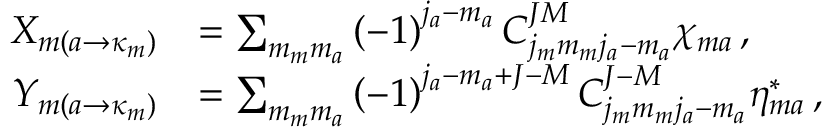<formula> <loc_0><loc_0><loc_500><loc_500>\begin{array} { r l } { X _ { m \left ( a \rightarrow \kappa _ { m } \right ) } } & { = \sum _ { m _ { m } m _ { a } } \left ( - 1 \right ) ^ { j _ { a } - m _ { a } } C _ { j _ { m } m _ { m } j _ { a } - m _ { a } } ^ { J M } \chi _ { m a } \, , } \\ { Y _ { m \left ( a \rightarrow \kappa _ { m } \right ) } } & { = \sum _ { m _ { m } m _ { a } } \left ( - 1 \right ) ^ { j _ { a } - m _ { a } + J - M } C _ { j _ { m } m _ { m } j _ { a } - m _ { a } } ^ { J - M } \eta _ { m a } ^ { * } \, , } \end{array}</formula> 